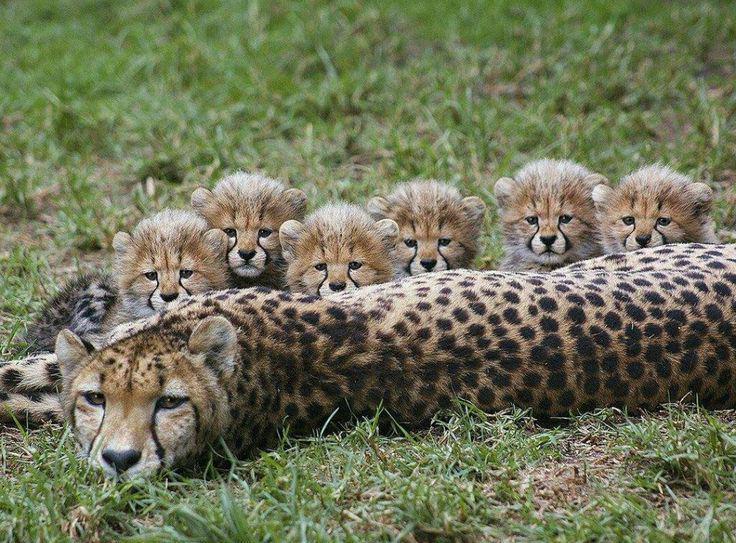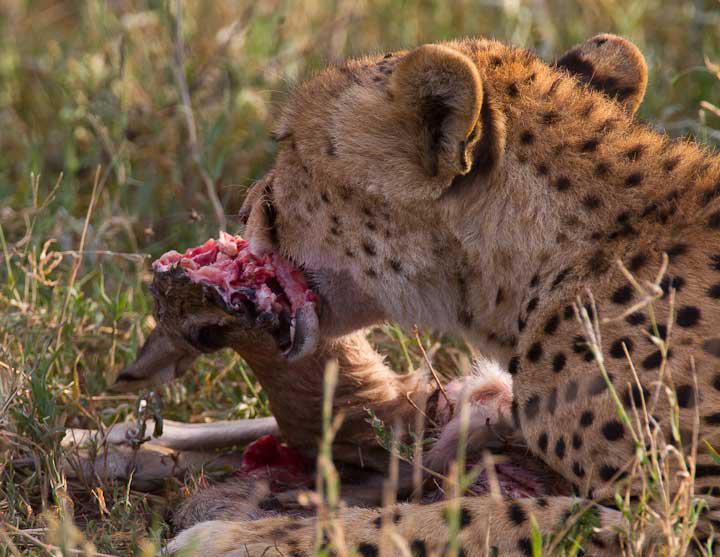The first image is the image on the left, the second image is the image on the right. Examine the images to the left and right. Is the description "In one of the images a cheetah can be seen with meat in its mouth." accurate? Answer yes or no. Yes. The first image is the image on the left, the second image is the image on the right. Considering the images on both sides, is "There are leopards and at least one deer." valid? Answer yes or no. No. 